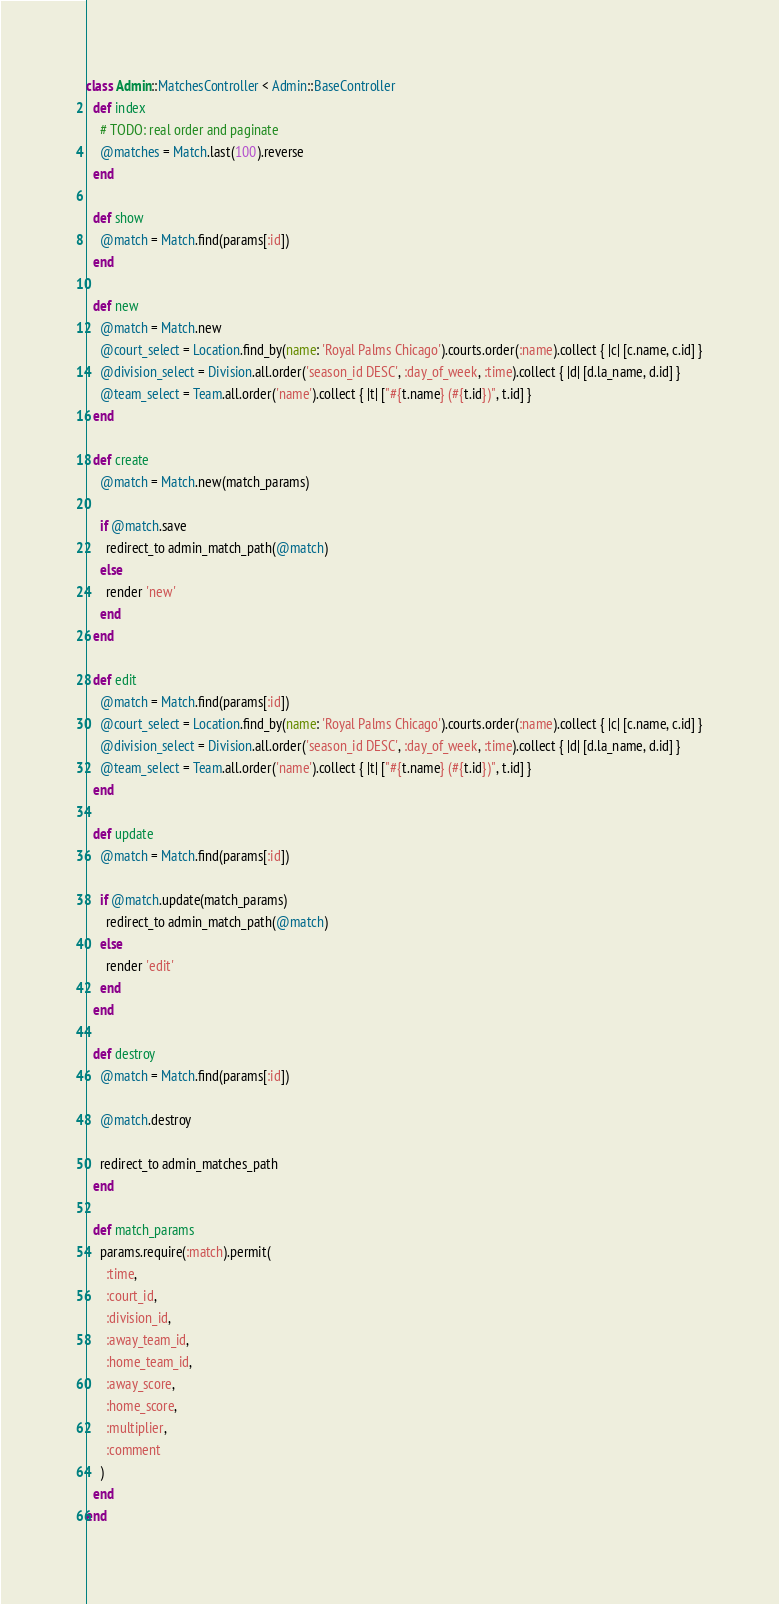Convert code to text. <code><loc_0><loc_0><loc_500><loc_500><_Ruby_>class Admin::MatchesController < Admin::BaseController
  def index
    # TODO: real order and paginate
    @matches = Match.last(100).reverse
  end

  def show
    @match = Match.find(params[:id])
  end

  def new
    @match = Match.new
    @court_select = Location.find_by(name: 'Royal Palms Chicago').courts.order(:name).collect { |c| [c.name, c.id] }
    @division_select = Division.all.order('season_id DESC', :day_of_week, :time).collect { |d| [d.la_name, d.id] }
    @team_select = Team.all.order('name').collect { |t| ["#{t.name} (#{t.id})", t.id] }
  end

  def create
    @match = Match.new(match_params)

    if @match.save
      redirect_to admin_match_path(@match)
    else
      render 'new'
    end
  end

  def edit
    @match = Match.find(params[:id])
    @court_select = Location.find_by(name: 'Royal Palms Chicago').courts.order(:name).collect { |c| [c.name, c.id] }
    @division_select = Division.all.order('season_id DESC', :day_of_week, :time).collect { |d| [d.la_name, d.id] }
    @team_select = Team.all.order('name').collect { |t| ["#{t.name} (#{t.id})", t.id] }
  end

  def update
    @match = Match.find(params[:id])

    if @match.update(match_params)
      redirect_to admin_match_path(@match)
    else
      render 'edit'
    end
  end

  def destroy
    @match = Match.find(params[:id])

    @match.destroy

    redirect_to admin_matches_path
  end

  def match_params
    params.require(:match).permit(
      :time,
      :court_id,
      :division_id,
      :away_team_id,
      :home_team_id,
      :away_score,
      :home_score,
      :multiplier,
      :comment
    )
  end
end
</code> 